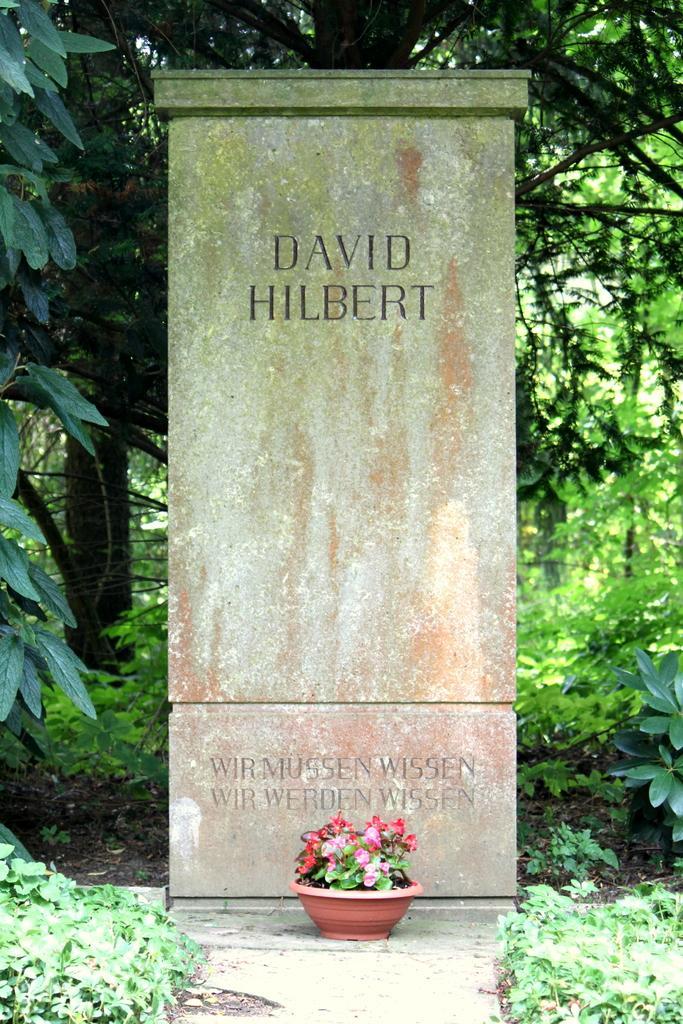How would you summarize this image in a sentence or two? There is a grave on which, there is a pot plant which is having flowers. On the both sides of this grave, there are plants. In the background, there are trees and plants on the ground. 